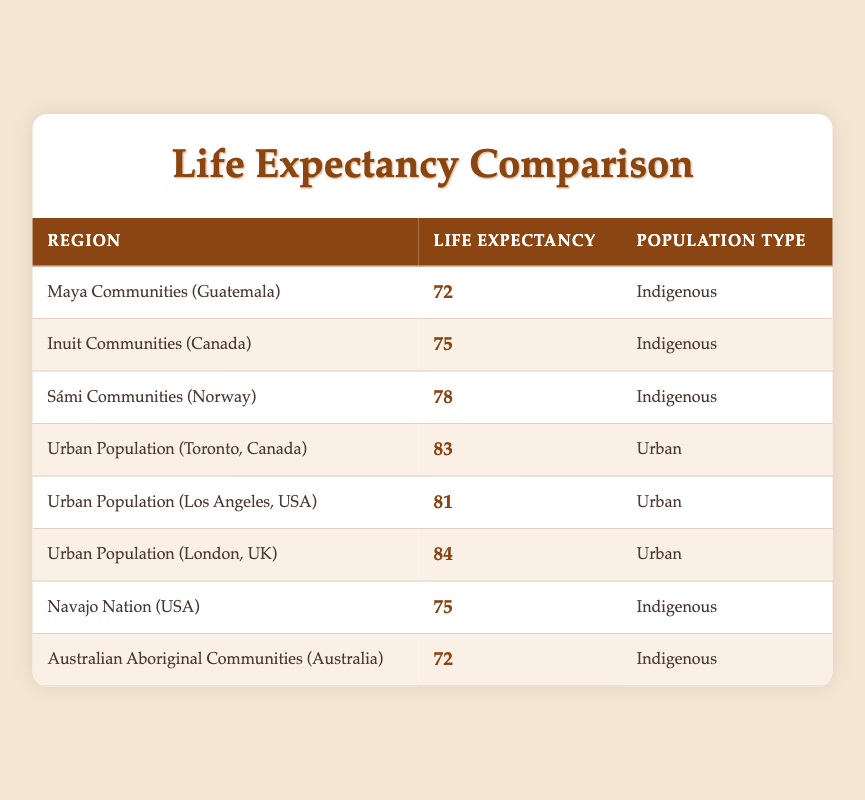What is the life expectancy of the Sámi Communities in Norway? According to the table, the life expectancy for Sámi Communities (Norway) is clearly stated as 78 years.
Answer: 78 What is the highest life expectancy value in the table? By examining all the life expectancies listed in the table, we find that the Urban Population (London, UK) has the highest life expectancy at 84 years.
Answer: 84 Are there more indigenous communities listed than urban populations? The table lists 4 indigenous communities (Maya, Inuit, Sámi, and Navajo Nation) and 3 urban populations (Toronto, Los Angeles, and London). Thus, there are more indigenous communities than urban populations, making the statement true.
Answer: Yes What is the average life expectancy of the indigenous communities? The life expectancies for indigenous communities are 72, 75, 78, 75, and 72. The total sum is 372 (72 + 75 + 78 + 75 + 72), and there are 5 communities. Thus, the average is 372/5 = 74.4, which rounds to 74 when considering whole years only.
Answer: 74 What is the difference in life expectancy between the Urban Population in Toronto and the Inuit Communities? The life expectancy in Toronto is 83 years, while the Inuit Communities have a life expectancy of 75 years. The difference is 83 - 75 = 8 years.
Answer: 8 What is the average life expectancy of urban populations? The life expectancies for urban populations are 83, 81, and 84. The total sum is 248 (83 + 81 + 84), and there are 3 populations. Thus, the average is 248/3 ≈ 82.67, which rounds to 83 when considering whole years only.
Answer: 83 Is the life expectancy of the Australian Aboriginal Communities equal to the Maya Communities? The life expectancy for the Australian Aboriginal Communities is 72 years, while the Maya Communities have a life expectancy of 72 years. Since both values are the same, the statement is true.
Answer: Yes Which population type has a higher average life expectancy, indigenous or urban? The average life expectancy for indigenous communities is 74.4 years, while for urban populations, it is 82.67 years. Since 82.67 is greater than 74.4, urban populations have a higher average life expectancy.
Answer: Urban populations 